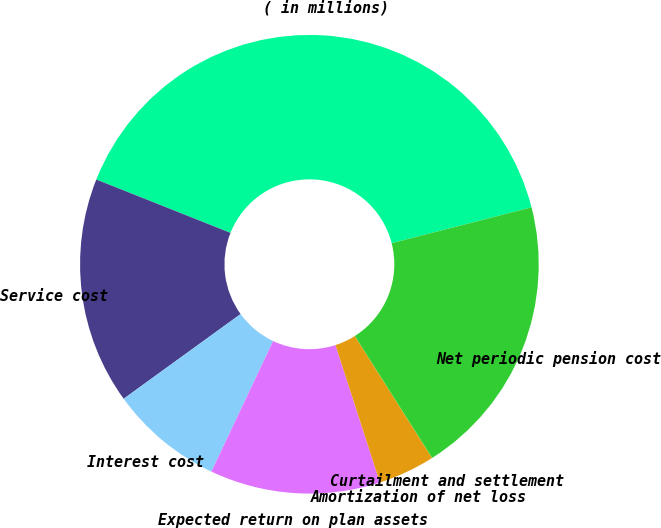<chart> <loc_0><loc_0><loc_500><loc_500><pie_chart><fcel>( in millions)<fcel>Service cost<fcel>Interest cost<fcel>Expected return on plan assets<fcel>Amortization of net loss<fcel>Curtailment and settlement<fcel>Net periodic pension cost<nl><fcel>39.99%<fcel>16.0%<fcel>8.0%<fcel>12.0%<fcel>4.01%<fcel>0.01%<fcel>20.0%<nl></chart> 